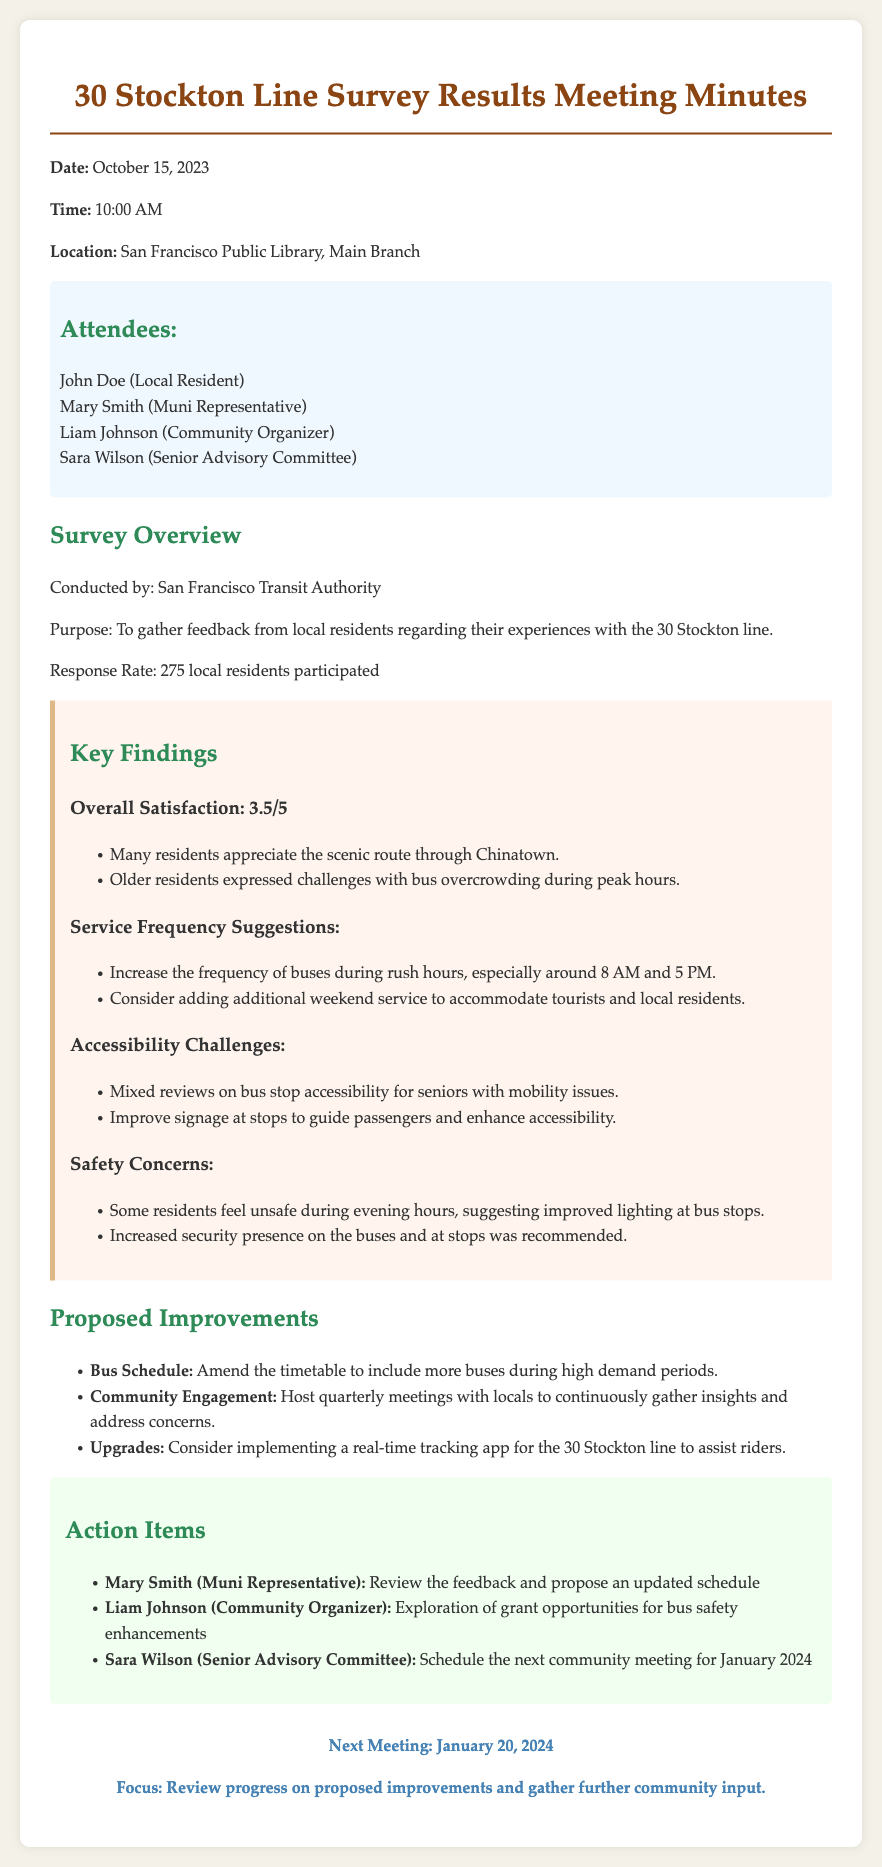What was the date of the meeting? The meeting was held on October 15, 2023, as indicated in the document.
Answer: October 15, 2023 Who conducted the survey? The survey was conducted by the San Francisco Transit Authority.
Answer: San Francisco Transit Authority What is the overall satisfaction rating from the survey? The overall satisfaction from the survey is noted as 3.5 out of 5.
Answer: 3.5/5 What time does the next meeting take place? The next meeting is scheduled for January 20, 2024, at 10:00 AM.
Answer: 10:00 AM What improvement is suggested for the bus schedule? The proposal includes amending the timetable to add more buses during high demand periods.
Answer: More buses during high demand periods How many residents participated in the survey? The total number of residents who participated in the survey is specified as 275.
Answer: 275 What safety concern was mentioned in the survey results? Residents expressed concerns about feeling unsafe during evening hours.
Answer: Feeling unsafe during evening hours Which committee member is responsible for scheduling the next community meeting? Sara Wilson from the Senior Advisory Committee is tasked with scheduling the next meeting.
Answer: Sara Wilson What suggestions were made for bus stop accessibility? Mixed reviews on bus stop accessibility for seniors with mobility issues were highlighted.
Answer: Mixed reviews on bus stop accessibility 